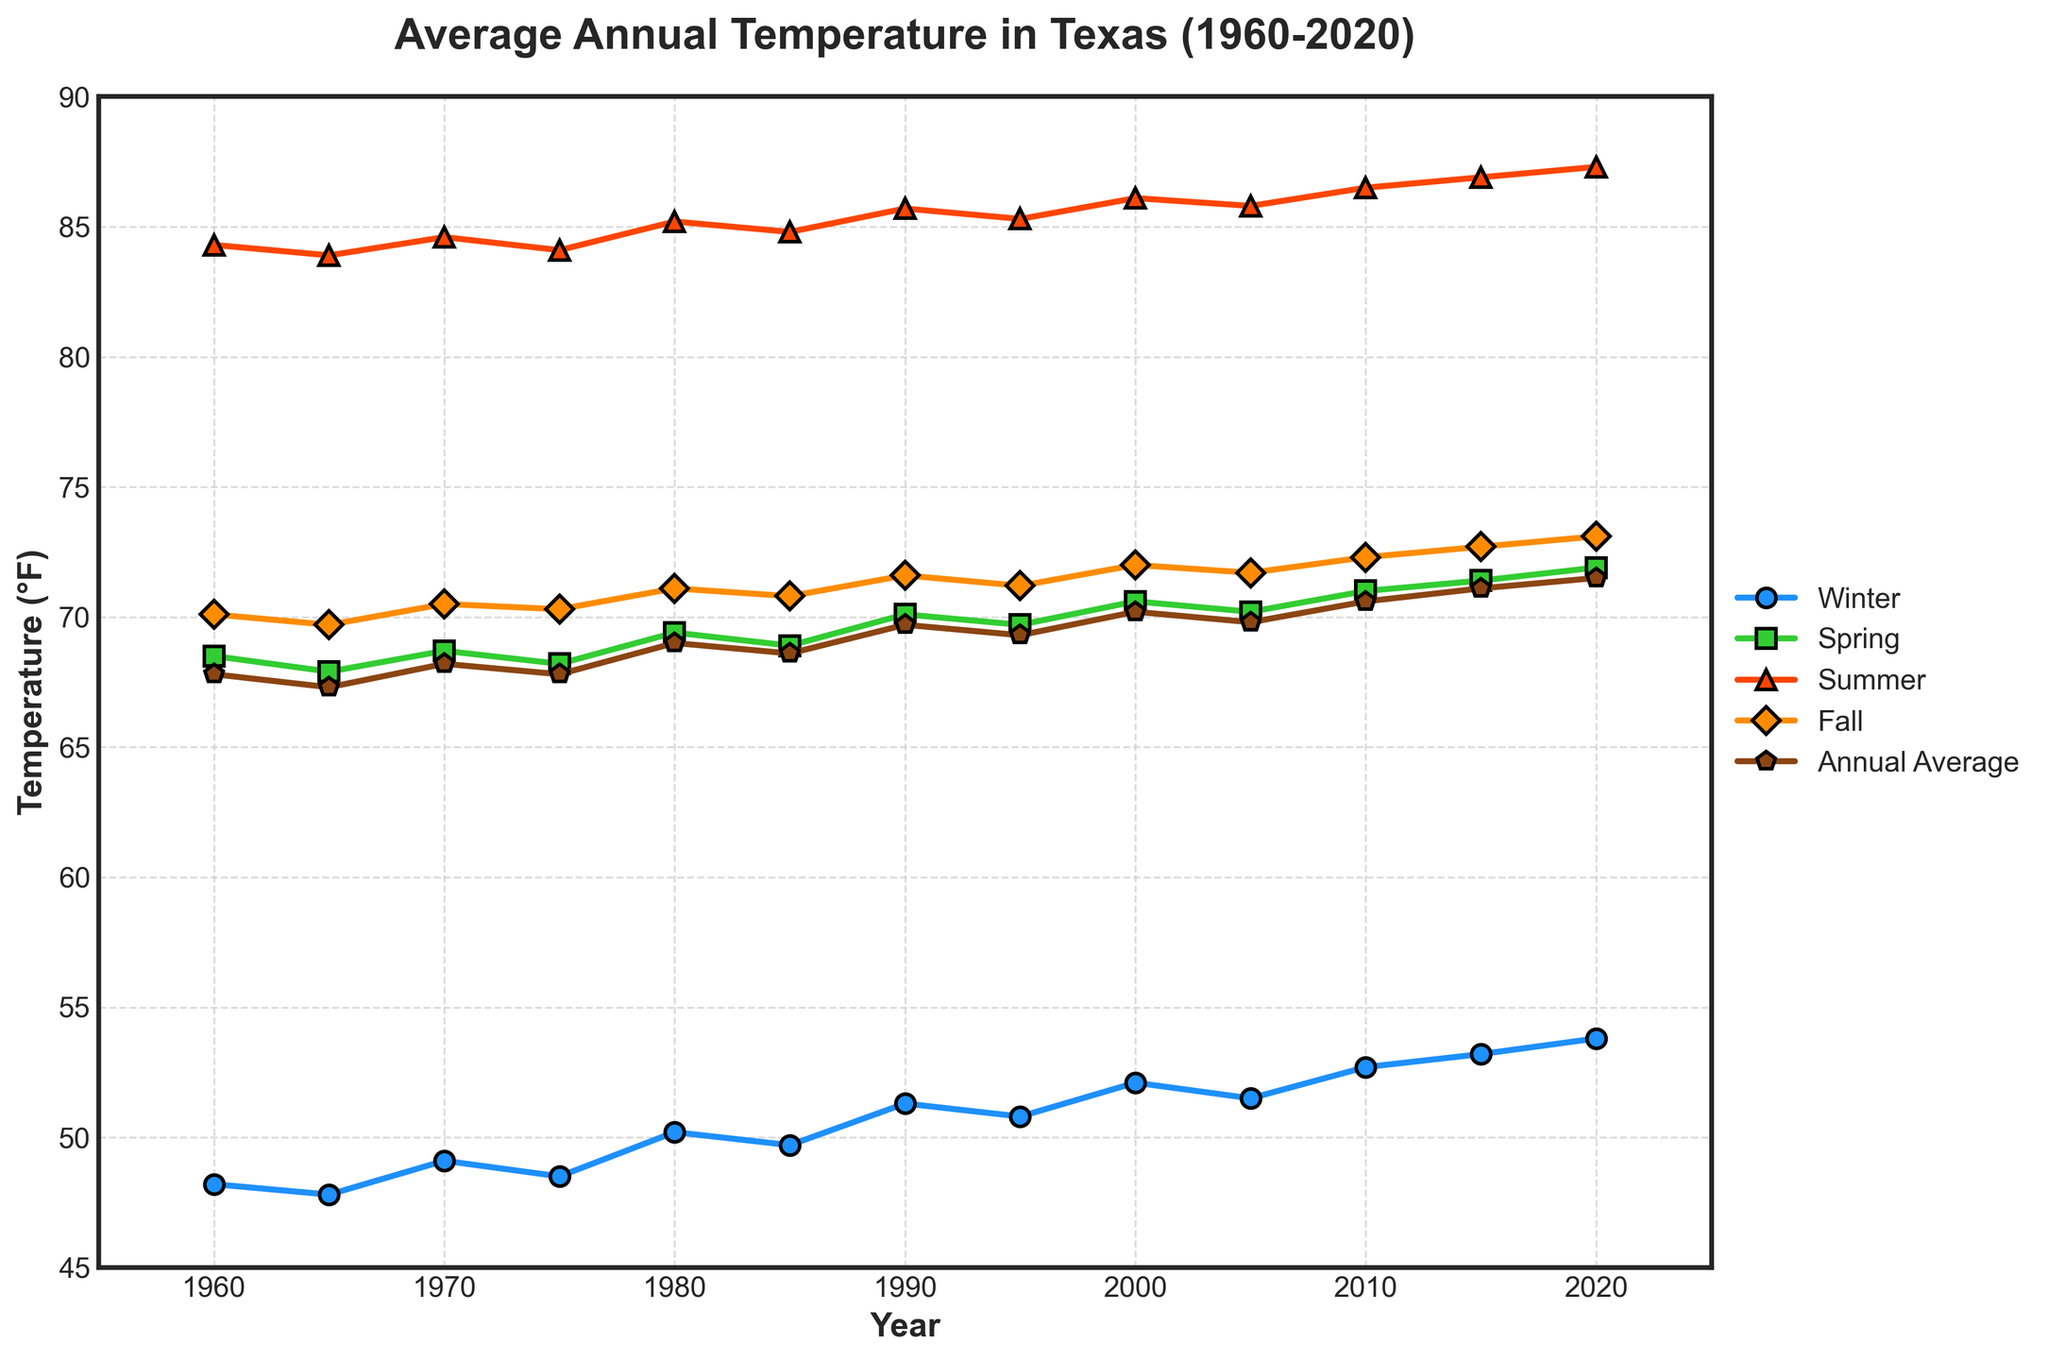What's the general trend of annual average temperature from 1960 to 2020? The annual average temperature shows an upward trend over time. According to the plot, temperatures have steadily increased from 67.8°F in 1960 to 71.5°F in 2020.
Answer: Upward trend What season experienced the highest temperature increase from 1960 to 2020? To determine the season with the highest temperature increase, calculate the difference between the 2020 and 1960 values for each season. The increases are: Winter (53.8 - 48.2 = 5.6), Spring (71.9 - 68.5 = 3.4), Summer (87.3 - 84.3 = 3.0), Fall (73.1 - 70.1 = 3.0). Winter experienced the highest increase of 5.6°F.
Answer: Winter Which year recorded the highest Fall temperature and what was it? Looking at the Fall temperatures plotted, the highest point occurs in the year 2020 with a temperature of 73.1°F.
Answer: 2020, 73.1°F Did the winter temperatures ever surpass the summer temperatures in any year from 1960 to 2020? By visually comparing the winter and summer temperature lines on the plot for each year, we can see that the summer temperatures are always higher than the winter temperatures throughout all years from 1960 to 2020.
Answer: No Compare the annual average temperature in 1980 and 2020. Which year was warmer and by how much? In 1980, the annual average temperature was 69.0°F, and in 2020 it was 71.5°F. To determine the difference, subtract 69.0 from 71.5, which gives 2.5°F. 2020 was warmer by 2.5°F.
Answer: 2020, by 2.5°F Which season had the least variation in temperatures from 1960 to 2020? To determine the season with the least variation, compare the range (difference between highest and lowest temperatures) for each season. Winter (53.8 - 47.8 = 6.0), Spring (71.9 - 67.9 = 4.0), Summer (87.3 - 83.9 = 3.4), Fall (73.1 - 69.7 = 3.4). Summer and Fall both had the least variation with a range of 3.4°F.
Answer: Summer and Fall In which year did Spring temperatures first exceed 70°F? By looking at the spring temperature trend on the plot, we observe that the Spring temperature first exceeds 70°F in 1990.
Answer: 1990 What was the temperature difference between the hottest Summer and the coldest Winter across all years? The hottest Summer temperature was 87.3°F in 2020. The coldest Winter temperature was 47.8°F in 1965. Subtracting these values gives a difference of 87.3 - 47.8 = 39.5°F.
Answer: 39.5°F Which two consecutive years had the most noticeable change in annual average temperature? To determine this, visually inspecting the changes in the annual average temperature line on the plot, the largest jump appears between 2010 (70.6°F) and 2015 (71.1°F), resulting in a 0.5°F increase.
Answer: 2010 and 2015, by 0.5°F 